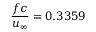<formula> <loc_0><loc_0><loc_500><loc_500>\frac { f c } { u _ { \infty } } = 0 . 3 3 5 9</formula> 